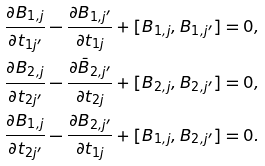Convert formula to latex. <formula><loc_0><loc_0><loc_500><loc_500>\frac { \partial B _ { 1 , j } } { \partial t _ { 1 j ^ { \prime } } } - \frac { \partial B _ { 1 , j ^ { \prime } } } { \partial t _ { 1 j } } + [ B _ { 1 , j } , B _ { 1 , j ^ { \prime } } ] & = 0 , \\ \frac { \partial B _ { 2 , j } } { \partial t _ { 2 j ^ { \prime } } } - \frac { \partial \bar { B } _ { 2 , j ^ { \prime } } } { \partial t _ { 2 j } } + [ B _ { 2 , j } , B _ { 2 , j ^ { \prime } } ] & = 0 , \\ \frac { \partial B _ { 1 , j } } { \partial t _ { 2 j ^ { \prime } } } - \frac { \partial B _ { 2 , j ^ { \prime } } } { \partial t _ { 1 j } } + [ B _ { 1 , j } , B _ { 2 , j ^ { \prime } } ] & = 0 .</formula> 